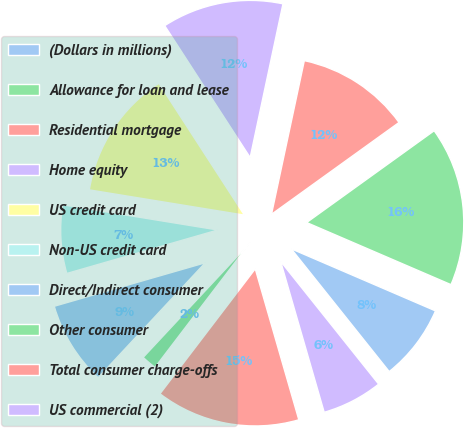Convert chart. <chart><loc_0><loc_0><loc_500><loc_500><pie_chart><fcel>(Dollars in millions)<fcel>Allowance for loan and lease<fcel>Residential mortgage<fcel>Home equity<fcel>US credit card<fcel>Non-US credit card<fcel>Direct/Indirect consumer<fcel>Other consumer<fcel>Total consumer charge-offs<fcel>US commercial (2)<nl><fcel>7.81%<fcel>16.4%<fcel>11.72%<fcel>12.5%<fcel>13.28%<fcel>7.03%<fcel>8.6%<fcel>1.57%<fcel>14.84%<fcel>6.25%<nl></chart> 